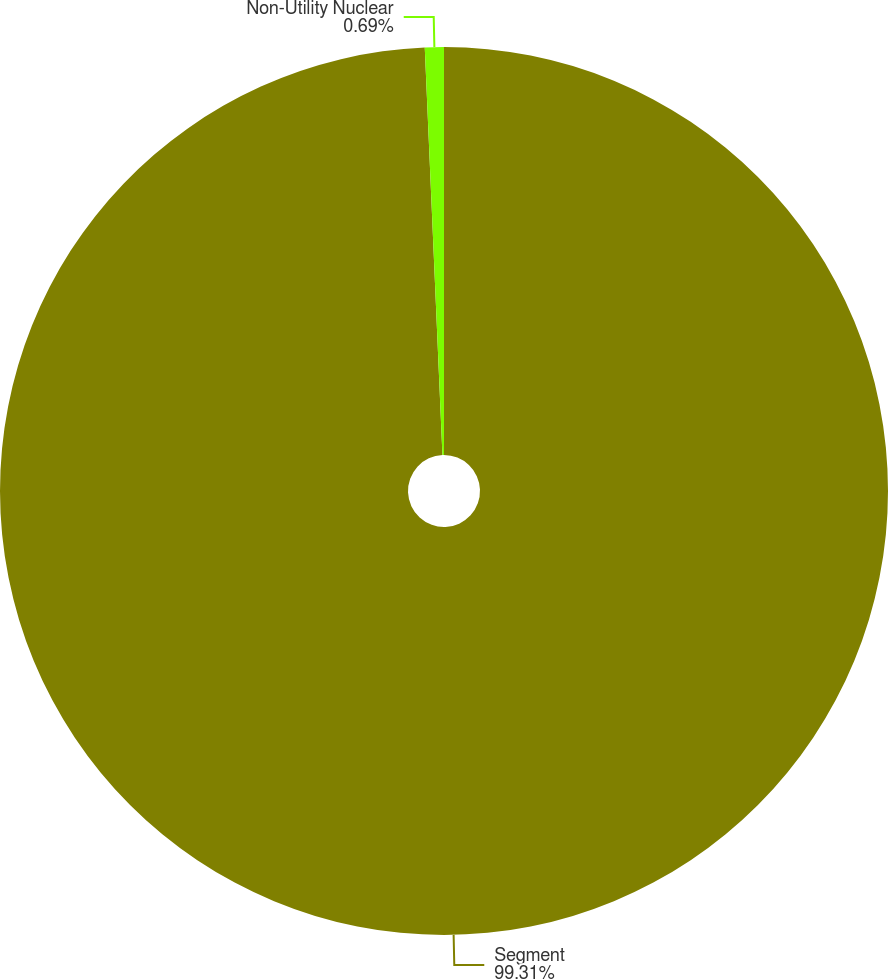Convert chart. <chart><loc_0><loc_0><loc_500><loc_500><pie_chart><fcel>Segment<fcel>Non-Utility Nuclear<nl><fcel>99.31%<fcel>0.69%<nl></chart> 